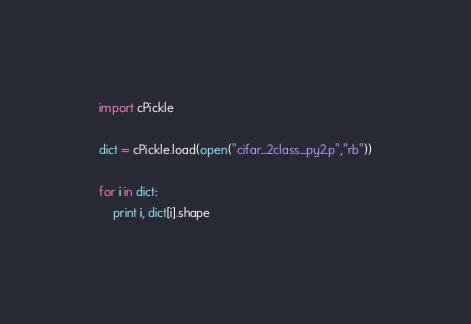<code> <loc_0><loc_0><loc_500><loc_500><_Python_>import cPickle

dict = cPickle.load(open("cifar_2class_py2.p","rb"))

for i in dict:
    print i, dict[i].shape</code> 